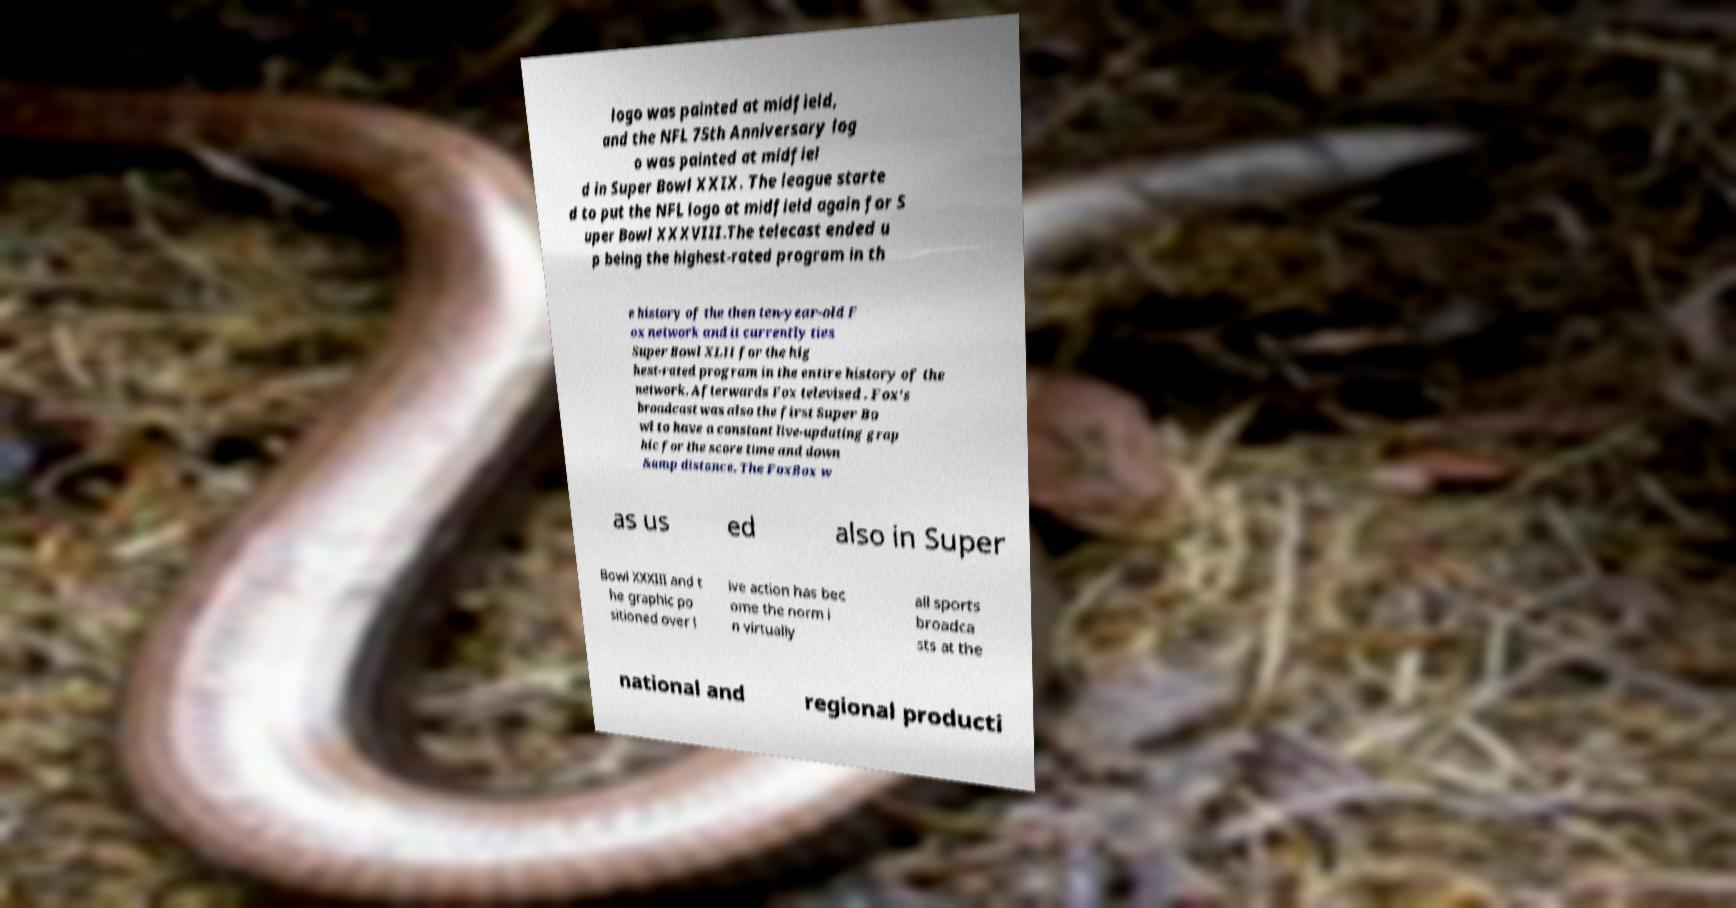Can you accurately transcribe the text from the provided image for me? logo was painted at midfield, and the NFL 75th Anniversary log o was painted at midfiel d in Super Bowl XXIX. The league starte d to put the NFL logo at midfield again for S uper Bowl XXXVIII.The telecast ended u p being the highest-rated program in th e history of the then ten-year-old F ox network and it currently ties Super Bowl XLII for the hig hest-rated program in the entire history of the network. Afterwards Fox televised . Fox's broadcast was also the first Super Bo wl to have a constant live-updating grap hic for the score time and down &amp distance. The FoxBox w as us ed also in Super Bowl XXXIII and t he graphic po sitioned over l ive action has bec ome the norm i n virtually all sports broadca sts at the national and regional producti 